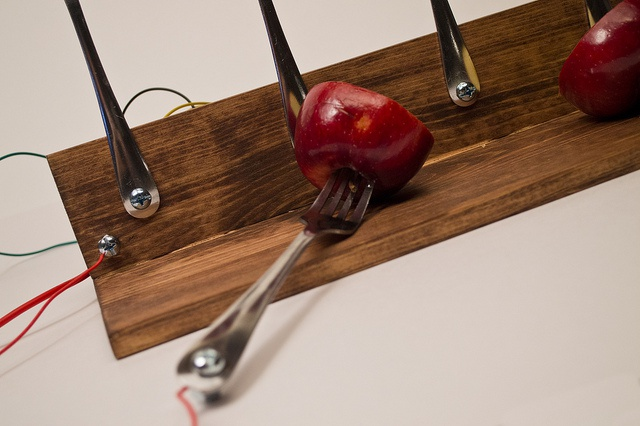Describe the objects in this image and their specific colors. I can see apple in lightgray, maroon, black, and brown tones, fork in lightgray, gray, black, maroon, and darkgray tones, and apple in lightgray, maroon, black, brown, and lightpink tones in this image. 